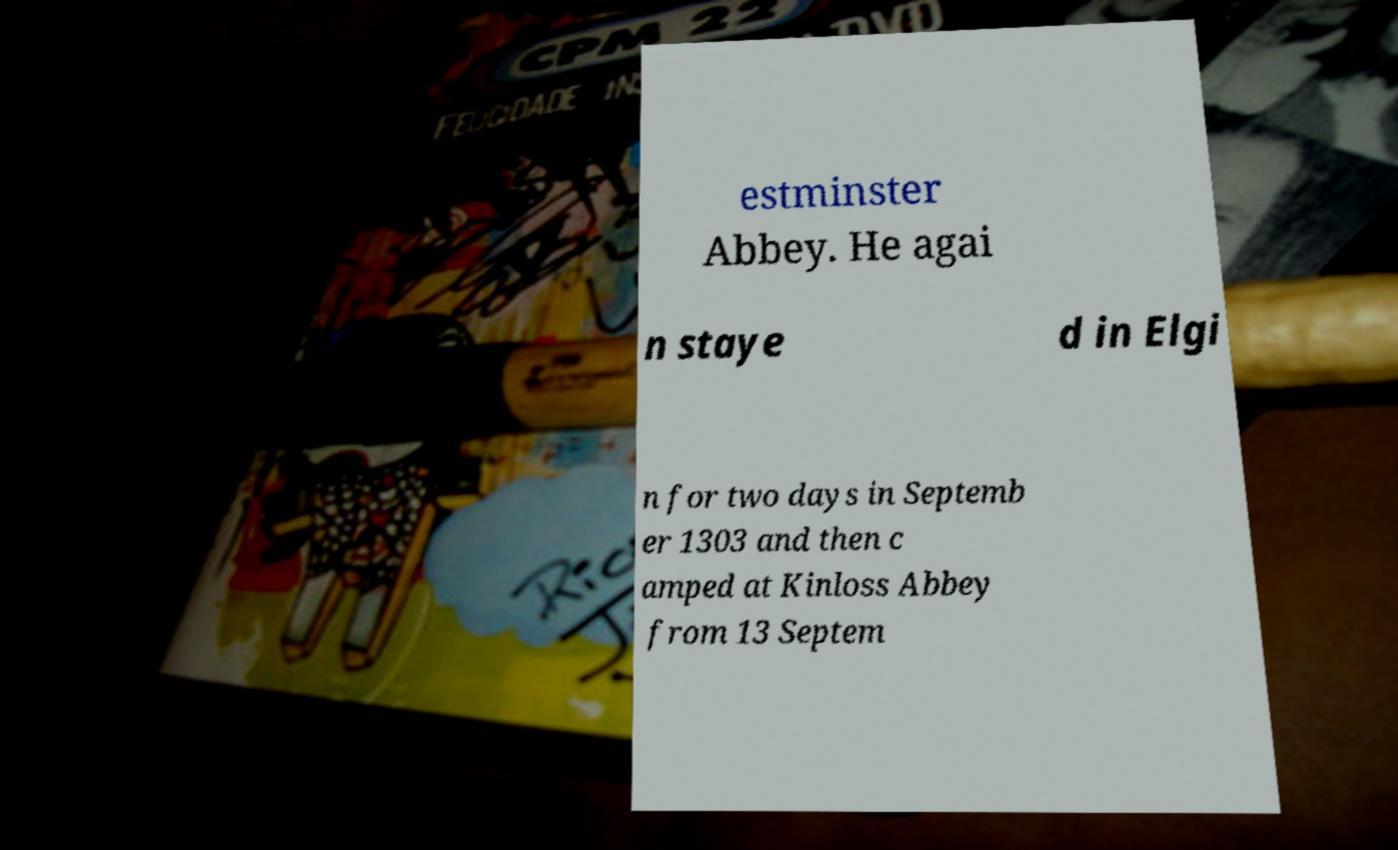I need the written content from this picture converted into text. Can you do that? estminster Abbey. He agai n staye d in Elgi n for two days in Septemb er 1303 and then c amped at Kinloss Abbey from 13 Septem 